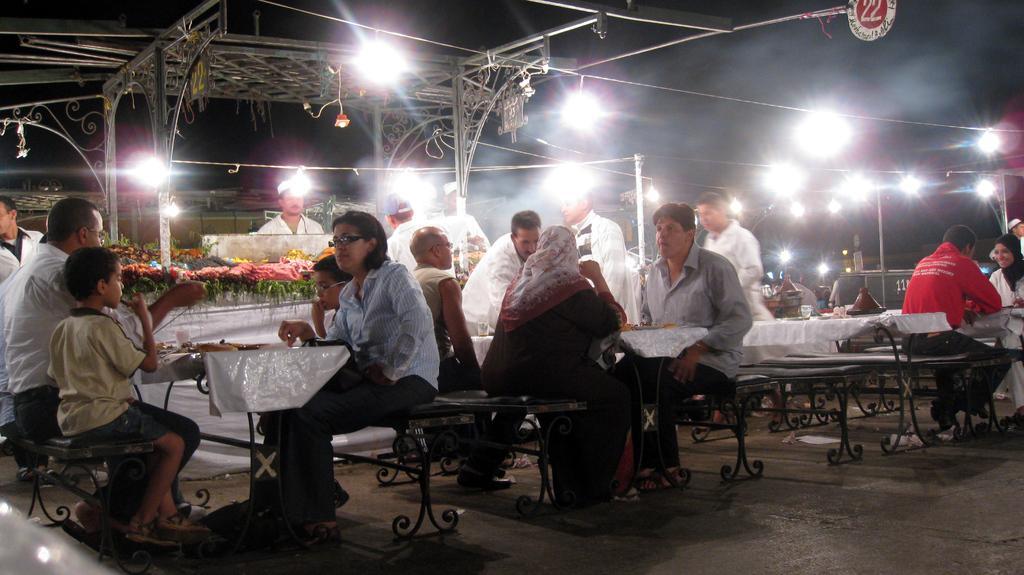Please provide a concise description of this image. There is a group of people. They are sitting in a chair. There is a table. There is a tissue ,food items on a table. In the background we can see lights and flowers. 